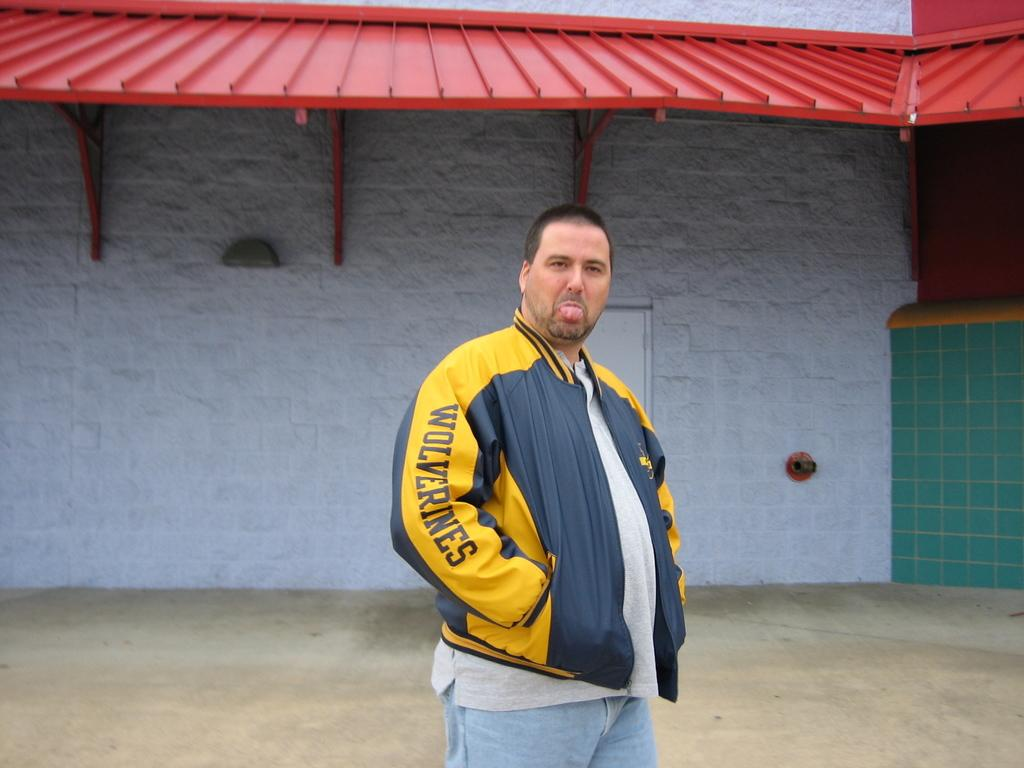Provide a one-sentence caption for the provided image. A fat man wearing a blue and yellow Wolverines jacket sticks his tongue out with his hands in his pockets. 